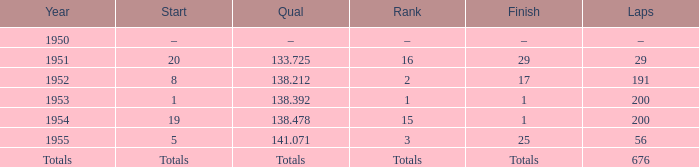What is the beginning of the race with 676 laps? Totals. 